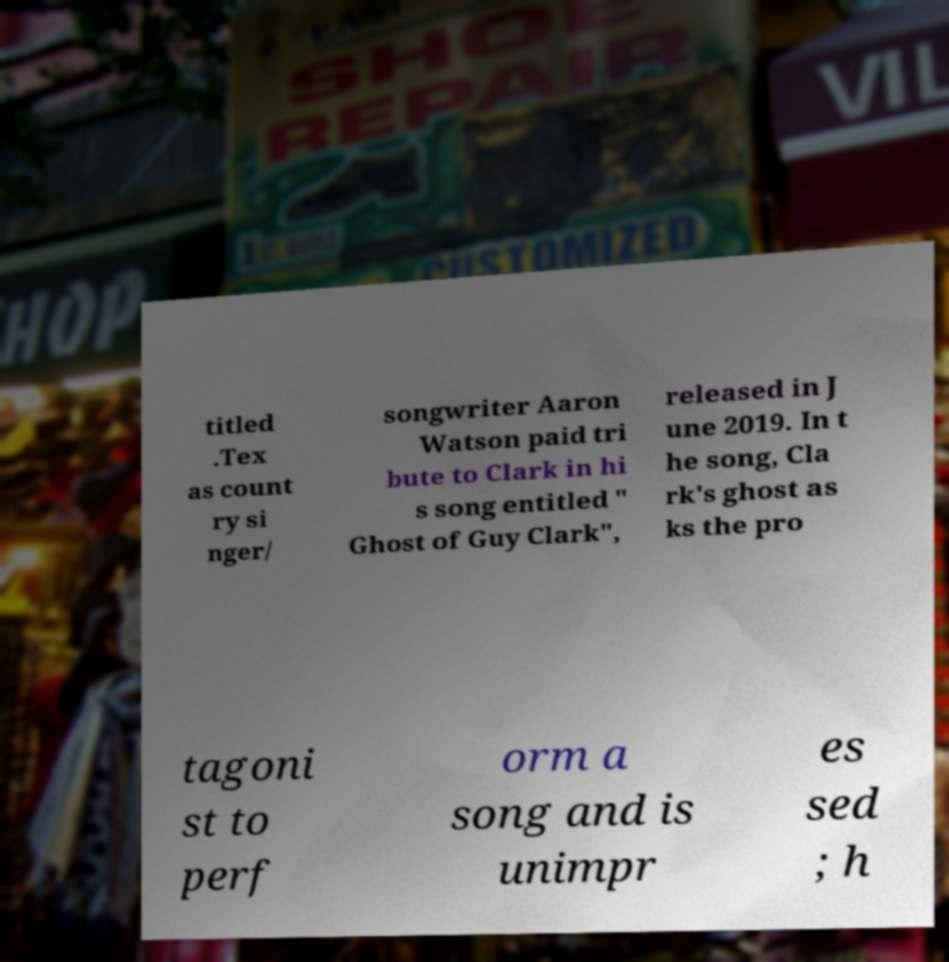Please identify and transcribe the text found in this image. titled .Tex as count ry si nger/ songwriter Aaron Watson paid tri bute to Clark in hi s song entitled " Ghost of Guy Clark", released in J une 2019. In t he song, Cla rk's ghost as ks the pro tagoni st to perf orm a song and is unimpr es sed ; h 